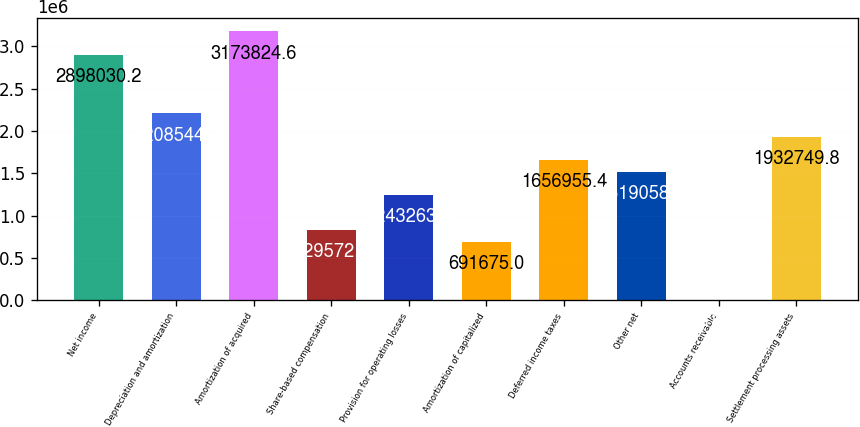Convert chart to OTSL. <chart><loc_0><loc_0><loc_500><loc_500><bar_chart><fcel>Net income<fcel>Depreciation and amortization<fcel>Amortization of acquired<fcel>Share-based compensation<fcel>Provision for operating losses<fcel>Amortization of capitalized<fcel>Deferred income taxes<fcel>Other net<fcel>Accounts receivable<fcel>Settlement processing assets<nl><fcel>2.89803e+06<fcel>2.20854e+06<fcel>3.17382e+06<fcel>829572<fcel>1.24326e+06<fcel>691675<fcel>1.65696e+06<fcel>1.51906e+06<fcel>2189<fcel>1.93275e+06<nl></chart> 